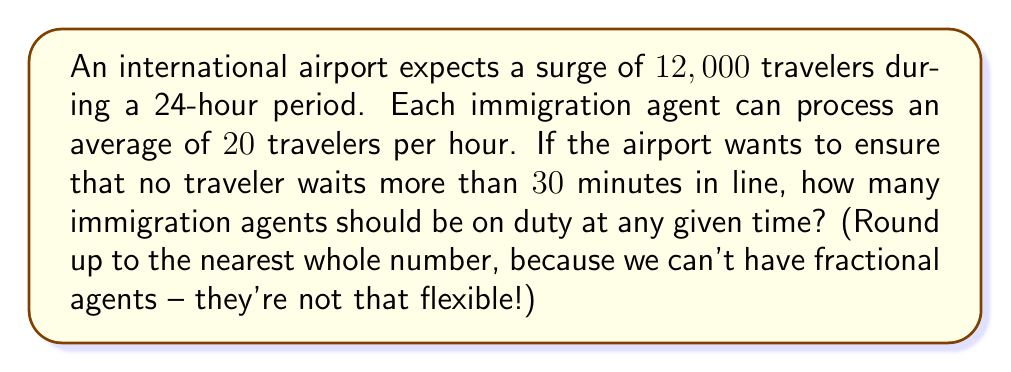Show me your answer to this math problem. Let's approach this step-by-step:

1) First, we need to calculate the number of travelers per hour:
   $$\frac{12,000 \text{ travelers}}{24 \text{ hours}} = 500 \text{ travelers/hour}$$

2) Now, we need to determine how many travelers can be processed in 30 minutes:
   $$500 \text{ travelers/hour} \times \frac{0.5 \text{ hours}}{1 \text{ hour}} = 250 \text{ travelers}$$

3) This means we need enough agents to process 250 travelers every 30 minutes.

4) Each agent can process 20 travelers per hour, or 10 travelers in 30 minutes:
   $$20 \text{ travelers/hour} \times \frac{0.5 \text{ hours}}{1 \text{ hour}} = 10 \text{ travelers}$$

5) To find the number of agents needed, we divide the number of travelers to be processed in 30 minutes by the number of travelers an agent can process in 30 minutes:
   $$\frac{250 \text{ travelers}}{10 \text{ travelers/agent}} = 25 \text{ agents}$$

6) Since we can't have fractional agents, we round up to the nearest whole number.
Answer: 25 agents 